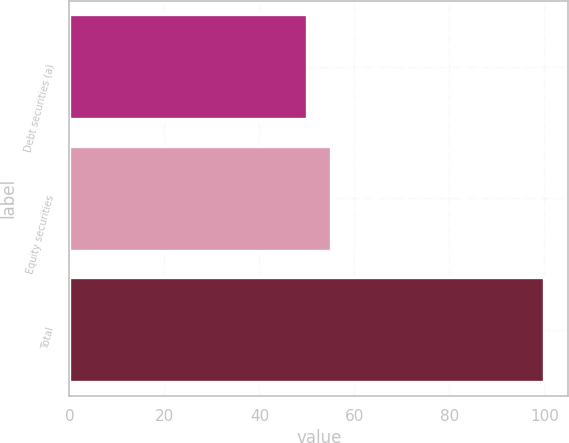<chart> <loc_0><loc_0><loc_500><loc_500><bar_chart><fcel>Debt securities (a)<fcel>Equity securities<fcel>Total<nl><fcel>50<fcel>55<fcel>100<nl></chart> 